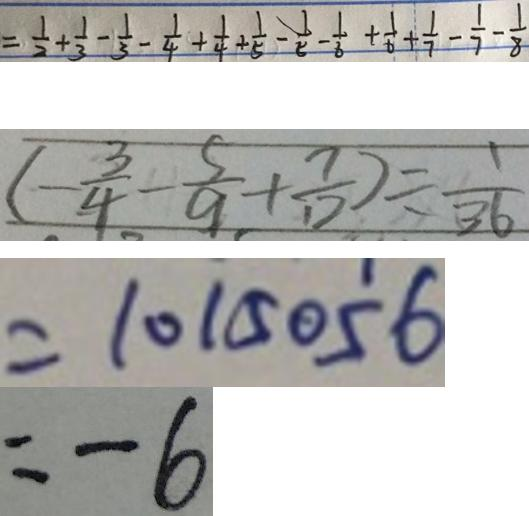Convert formula to latex. <formula><loc_0><loc_0><loc_500><loc_500>= \frac { 1 } { 2 } + \frac { 1 } { 3 } - \frac { 1 } { 3 } - \frac { 1 } { 4 } + \frac { 1 } { 4 } + \frac { 1 } { 5 } - \frac { 1 } { 5 } - \frac { 1 } { 6 } + \frac { 1 } { 6 } + \frac { 1 } { 7 } - \frac { 1 } { 7 } - \frac { 1 } { 8 } 
 ( - \frac { 3 } { 4 } - \frac { 5 } { 9 } + \frac { 7 } { 1 2 } ) = \frac { 1 } { 3 6 } 
 = 1 0 1 5 0 5 6 
 = - 6</formula> 